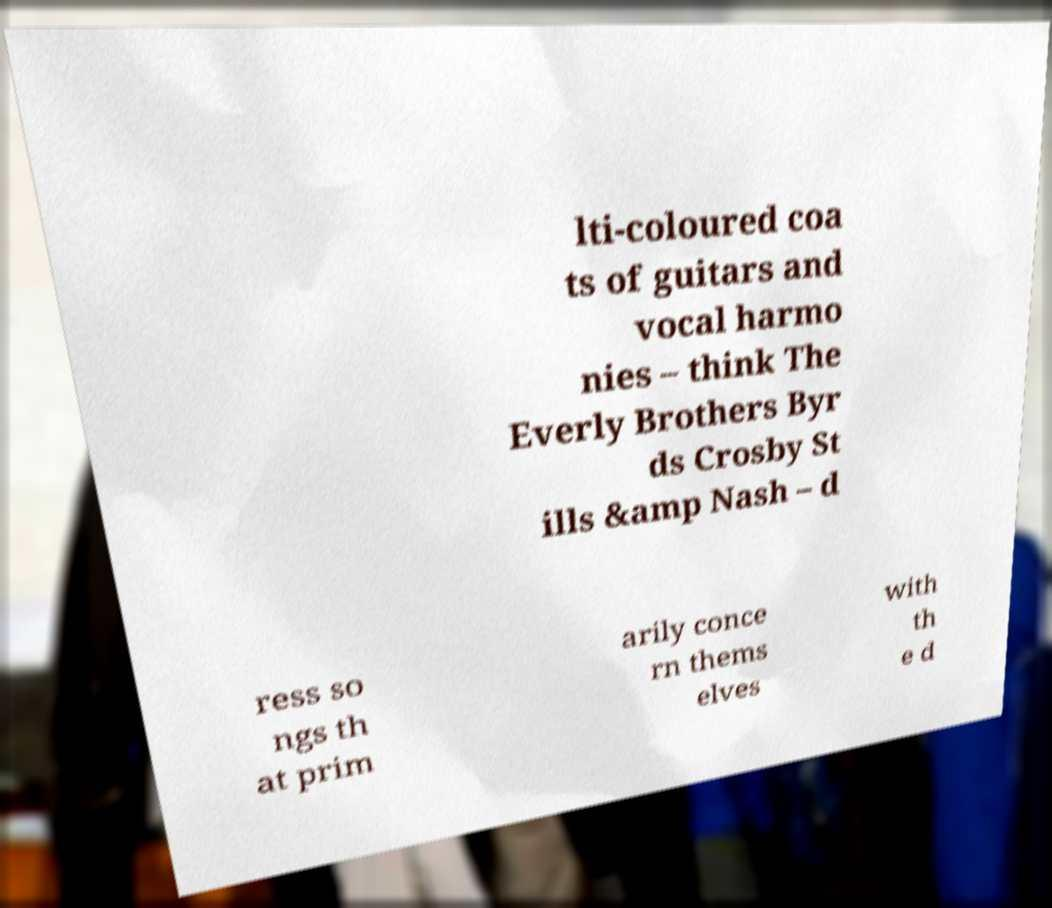Please read and relay the text visible in this image. What does it say? lti-coloured coa ts of guitars and vocal harmo nies – think The Everly Brothers Byr ds Crosby St ills &amp Nash – d ress so ngs th at prim arily conce rn thems elves with th e d 